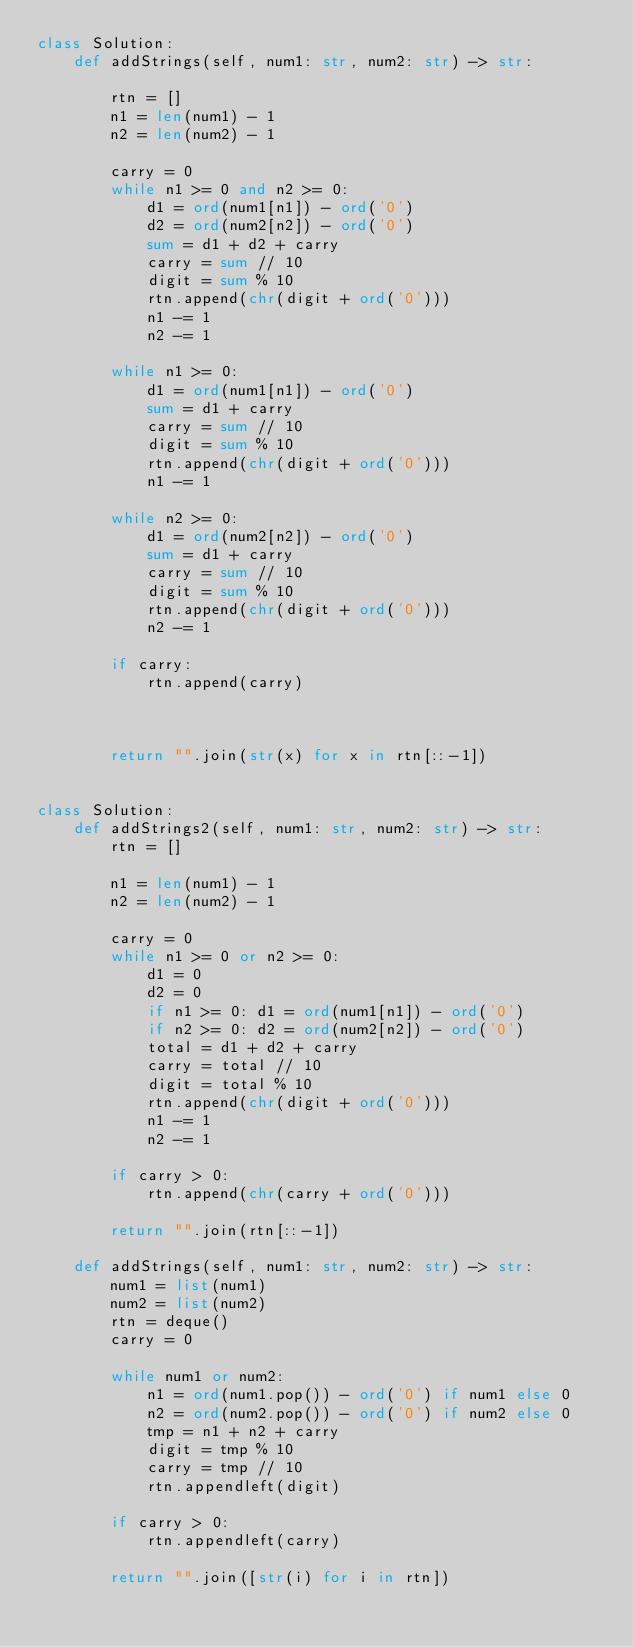<code> <loc_0><loc_0><loc_500><loc_500><_Python_>class Solution:
    def addStrings(self, num1: str, num2: str) -> str:
        
        rtn = []
        n1 = len(num1) - 1
        n2 = len(num2) - 1
        
        carry = 0
        while n1 >= 0 and n2 >= 0:
            d1 = ord(num1[n1]) - ord('0')
            d2 = ord(num2[n2]) - ord('0')
            sum = d1 + d2 + carry
            carry = sum // 10
            digit = sum % 10
            rtn.append(chr(digit + ord('0')))
            n1 -= 1
            n2 -= 1
            
        while n1 >= 0:
            d1 = ord(num1[n1]) - ord('0')
            sum = d1 + carry
            carry = sum // 10
            digit = sum % 10
            rtn.append(chr(digit + ord('0')))
            n1 -= 1

        while n2 >= 0:
            d1 = ord(num2[n2]) - ord('0')
            sum = d1 + carry
            carry = sum // 10
            digit = sum % 10
            rtn.append(chr(digit + ord('0')))
            n2 -= 1
        
        if carry:
            rtn.append(carry)
        
        
    
        return "".join(str(x) for x in rtn[::-1])


class Solution:
    def addStrings2(self, num1: str, num2: str) -> str:
        rtn = []
        
        n1 = len(num1) - 1
        n2 = len(num2) - 1
        
        carry = 0
        while n1 >= 0 or n2 >= 0:
            d1 = 0
            d2 = 0
            if n1 >= 0: d1 = ord(num1[n1]) - ord('0')
            if n2 >= 0: d2 = ord(num2[n2]) - ord('0')
            total = d1 + d2 + carry
            carry = total // 10
            digit = total % 10
            rtn.append(chr(digit + ord('0')))
            n1 -= 1
            n2 -= 1
        
        if carry > 0:
            rtn.append(chr(carry + ord('0')))
        
        return "".join(rtn[::-1])

    def addStrings(self, num1: str, num2: str) -> str:
        num1 = list(num1)
        num2 = list(num2)
        rtn = deque()
        carry = 0
        
        while num1 or num2:
            n1 = ord(num1.pop()) - ord('0') if num1 else 0
            n2 = ord(num2.pop()) - ord('0') if num2 else 0
            tmp = n1 + n2 + carry
            digit = tmp % 10
            carry = tmp // 10
            rtn.appendleft(digit)
        
        if carry > 0:
            rtn.appendleft(carry)
        
        return "".join([str(i) for i in rtn])</code> 